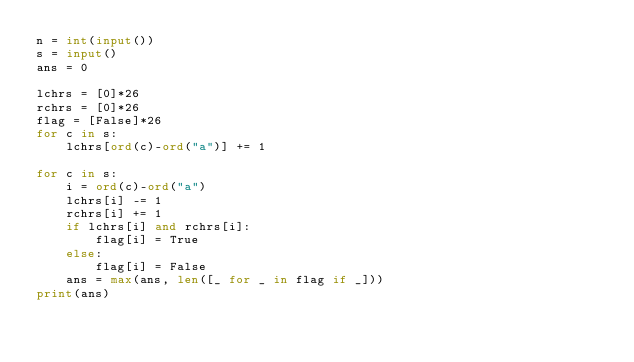<code> <loc_0><loc_0><loc_500><loc_500><_Python_>n = int(input())
s = input()
ans = 0

lchrs = [0]*26
rchrs = [0]*26
flag = [False]*26
for c in s:
    lchrs[ord(c)-ord("a")] += 1

for c in s:
    i = ord(c)-ord("a")
    lchrs[i] -= 1
    rchrs[i] += 1
    if lchrs[i] and rchrs[i]:
        flag[i] = True
    else:
        flag[i] = False
    ans = max(ans, len([_ for _ in flag if _]))
print(ans)
</code> 